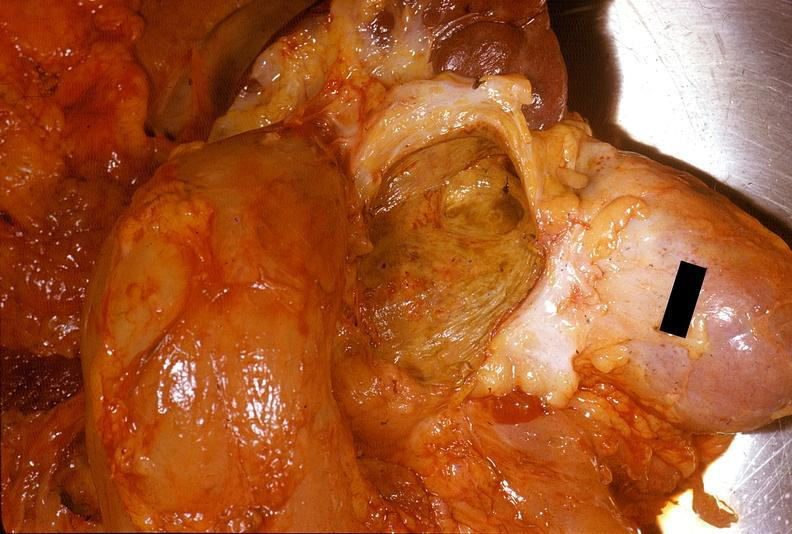how does this image show chronic pancreatitis?
Answer the question using a single word or phrase. With cyst formation 